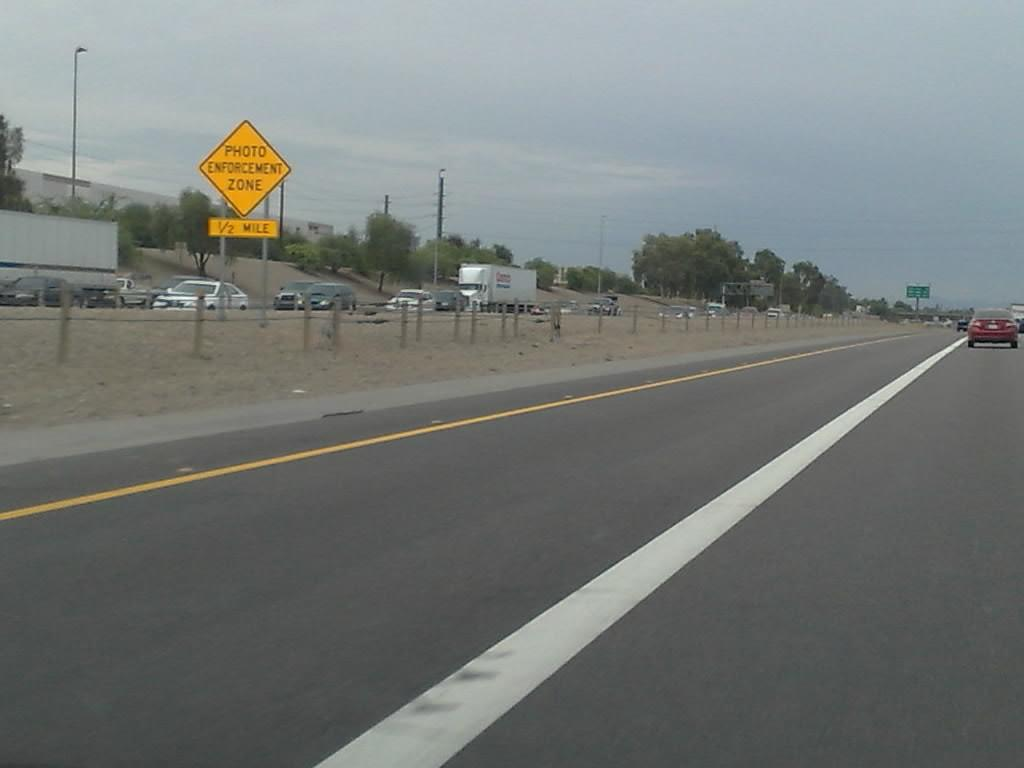Provide a one-sentence caption for the provided image. A yellow sign saying Photo Enforcement Zone stands int the middle of the reservation of a busy road. 